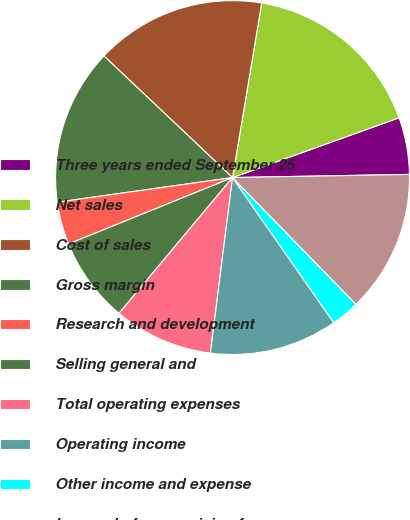Convert chart. <chart><loc_0><loc_0><loc_500><loc_500><pie_chart><fcel>Three years ended September 25<fcel>Net sales<fcel>Cost of sales<fcel>Gross margin<fcel>Research and development<fcel>Selling general and<fcel>Total operating expenses<fcel>Operating income<fcel>Other income and expense<fcel>Income before provision for<nl><fcel>5.2%<fcel>16.88%<fcel>15.58%<fcel>14.28%<fcel>3.9%<fcel>7.79%<fcel>9.09%<fcel>11.69%<fcel>2.6%<fcel>12.99%<nl></chart> 